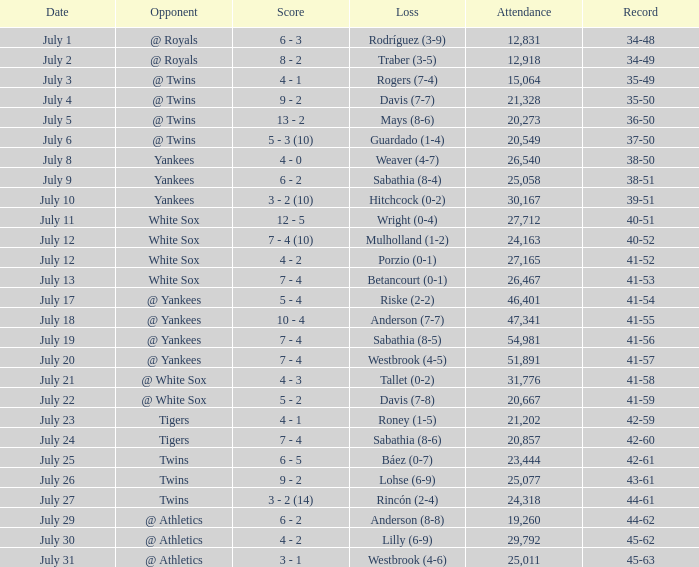Which Record has an Opponent of twins, and a Date of july 25? 42-61. 